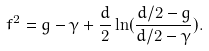<formula> <loc_0><loc_0><loc_500><loc_500>f ^ { 2 } = g - \gamma + \frac { d } { 2 } \ln ( \frac { d / 2 - g } { d / 2 - \gamma } ) .</formula> 